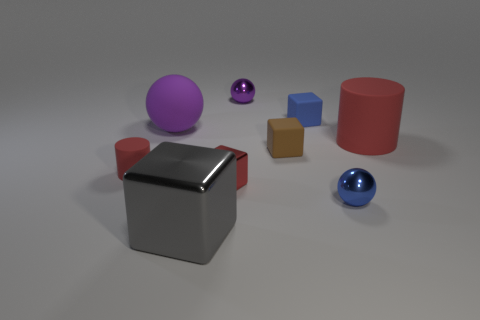Subtract all blue cylinders. Subtract all blue spheres. How many cylinders are left? 2 Add 1 tiny purple spheres. How many objects exist? 10 Subtract all blocks. How many objects are left? 5 Add 9 big cylinders. How many big cylinders are left? 10 Add 2 rubber objects. How many rubber objects exist? 7 Subtract 0 brown cylinders. How many objects are left? 9 Subtract all large spheres. Subtract all metal things. How many objects are left? 4 